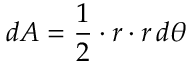Convert formula to latex. <formula><loc_0><loc_0><loc_500><loc_500>d A = { \frac { 1 } { 2 } } \cdot r \cdot r \, d \theta</formula> 